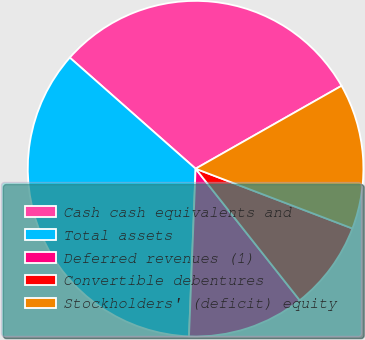Convert chart. <chart><loc_0><loc_0><loc_500><loc_500><pie_chart><fcel>Cash cash equivalents and<fcel>Total assets<fcel>Deferred revenues (1)<fcel>Convertible debentures<fcel>Stockholders' (deficit) equity<nl><fcel>30.27%<fcel>35.89%<fcel>11.28%<fcel>8.55%<fcel>14.02%<nl></chart> 